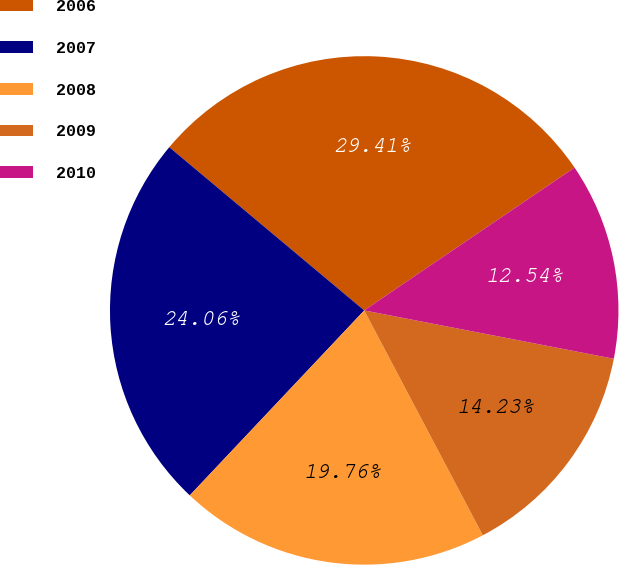<chart> <loc_0><loc_0><loc_500><loc_500><pie_chart><fcel>2006<fcel>2007<fcel>2008<fcel>2009<fcel>2010<nl><fcel>29.41%<fcel>24.06%<fcel>19.76%<fcel>14.23%<fcel>12.54%<nl></chart> 